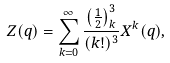<formula> <loc_0><loc_0><loc_500><loc_500>Z ( q ) = \sum _ { k = 0 } ^ { \infty } \frac { \left ( \frac { 1 } { 2 } \right ) _ { k } ^ { 3 } } { ( k ! ) ^ { 3 } } X ^ { k } ( q ) ,</formula> 